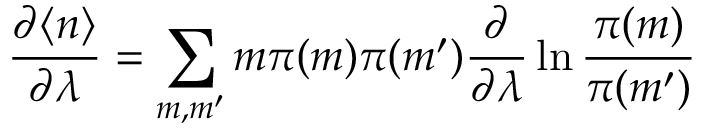Convert formula to latex. <formula><loc_0><loc_0><loc_500><loc_500>\frac { \partial \langle n \rangle } { \partial \lambda } = \sum _ { m , m ^ { \prime } } m \pi ( m ) \pi ( m ^ { \prime } ) \frac { \partial } { \partial \lambda } \ln \frac { \pi ( m ) } { \pi ( m ^ { \prime } ) }</formula> 